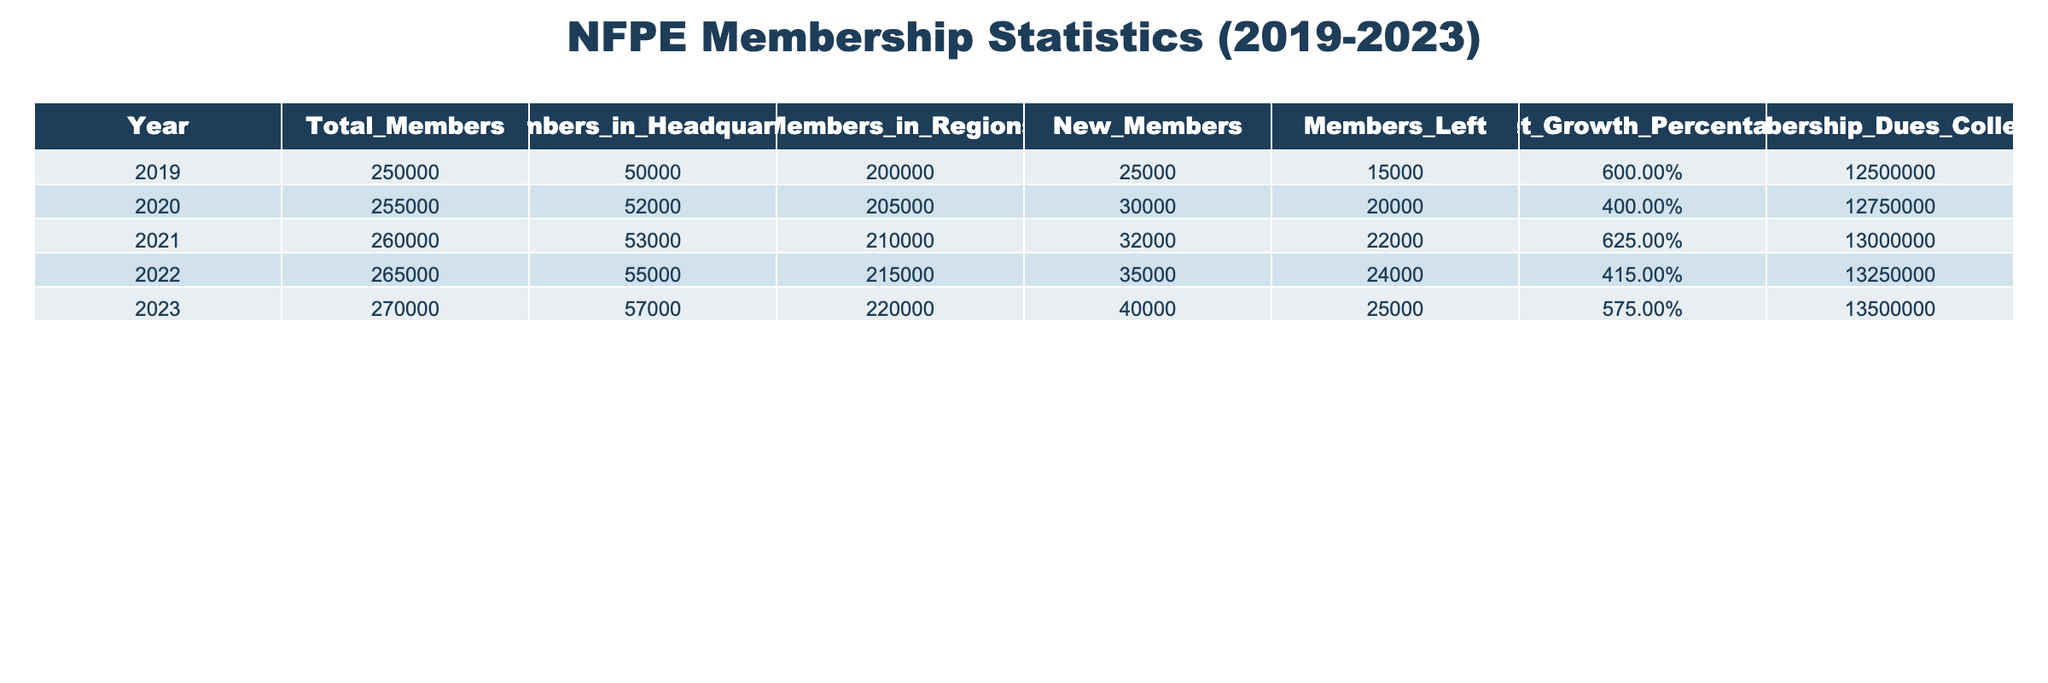What was the total membership in 2021? The total membership for the year 2021 is specifically provided in the table as 260,000.
Answer: 260,000 What were the membership dues collected in 2020? The dues collected in 2020 can be found in the table under the "Membership Dues Collected" column, which shows a total of 12,750,000.
Answer: 12,750,000 What is the net growth percentage for the year 2023? The net growth percentage for 2023 is listed in the table as 5.75%.
Answer: 5.75% How many new members joined between 2020 and 2023? The new members from 2020 to 2023 are calculated by subtracting the new members in 2020 (30,000) from the new members in 2023 (40,000), totaling to 40,000 - 30,000 = 10,000.
Answer: 10,000 Did the total membership decrease at any point from 2019 to 2023? By examining the total membership for each year from 2019 to 2023, it shows a consistent increase each year, indicating there were no decreases.
Answer: No What was the average number of members in headquarters over the last five years? The total members in headquarters over the five years are 50,000 + 52,000 + 53,000 + 55,000 + 57,000 = 267,000. Dividing by 5 gives an average of 267,000 / 5 = 53,400.
Answer: 53,400 What is the overall increase in total members from 2019 to 2023? To find the overall increase, subtract the total membership in 2019 (250,000) from the total membership in 2023 (270,000), resulting in 270,000 - 250,000 = 20,000.
Answer: 20,000 What was the highest number of new members recorded in a single year? By reviewing the "New Members" column, the highest number recorded is 40,000 in 2023.
Answer: 40,000 What percentage of members left in 2022 compared to the total membership that year? In 2022, members left equals 24,000 and the total membership is 265,000. The percentage is (24,000 / 265,000) * 100 ≈ 9.06%.
Answer: 9.06% Which year had the highest membership dues collected? The highest membership dues collected were in 2023, totaling 13,500,000, as indicated in the table.
Answer: 13,500,000 